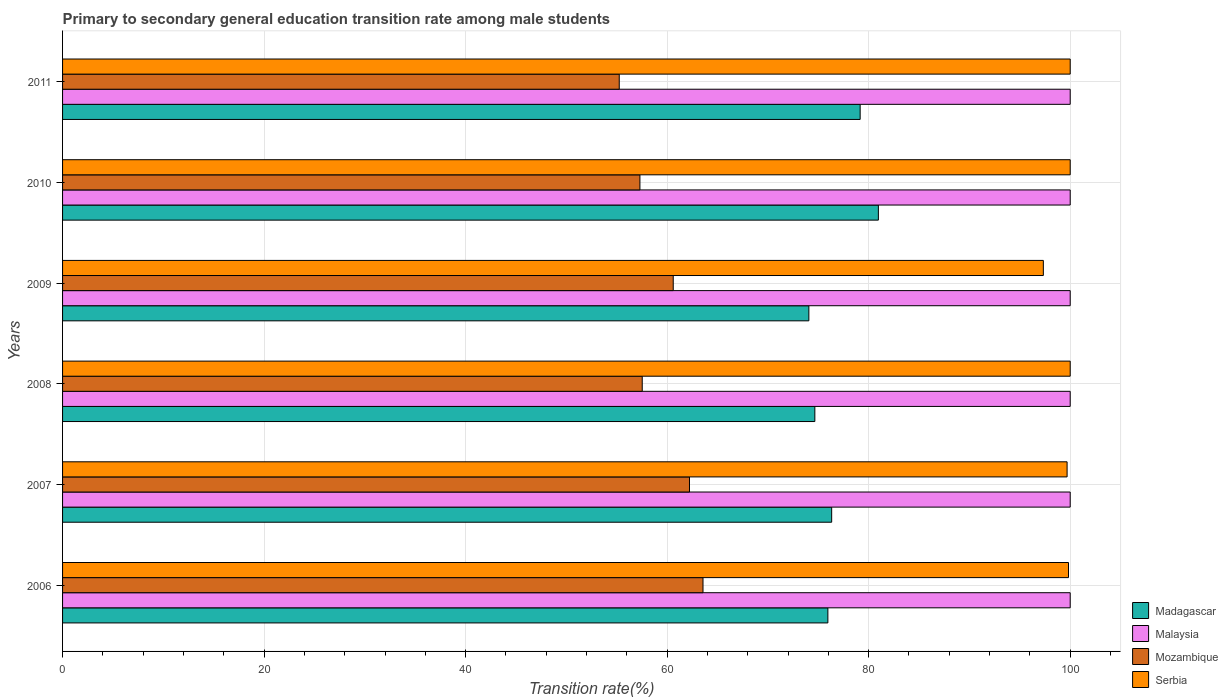How many groups of bars are there?
Make the answer very short. 6. Are the number of bars per tick equal to the number of legend labels?
Your response must be concise. Yes. What is the label of the 1st group of bars from the top?
Your response must be concise. 2011. What is the transition rate in Serbia in 2006?
Provide a succinct answer. 99.83. Across all years, what is the maximum transition rate in Serbia?
Your response must be concise. 100. Across all years, what is the minimum transition rate in Serbia?
Your response must be concise. 97.33. What is the total transition rate in Madagascar in the graph?
Your answer should be compact. 461.12. What is the difference between the transition rate in Malaysia in 2006 and that in 2009?
Your answer should be very brief. 0. What is the difference between the transition rate in Mozambique in 2006 and the transition rate in Malaysia in 2011?
Give a very brief answer. -36.44. What is the average transition rate in Mozambique per year?
Make the answer very short. 59.41. In the year 2009, what is the difference between the transition rate in Serbia and transition rate in Madagascar?
Your answer should be very brief. 23.27. In how many years, is the transition rate in Mozambique greater than 92 %?
Your answer should be very brief. 0. Is the difference between the transition rate in Serbia in 2006 and 2009 greater than the difference between the transition rate in Madagascar in 2006 and 2009?
Ensure brevity in your answer.  Yes. What is the difference between the highest and the lowest transition rate in Madagascar?
Your answer should be compact. 6.9. Is it the case that in every year, the sum of the transition rate in Mozambique and transition rate in Serbia is greater than the sum of transition rate in Malaysia and transition rate in Madagascar?
Give a very brief answer. Yes. What does the 3rd bar from the top in 2009 represents?
Ensure brevity in your answer.  Malaysia. What does the 1st bar from the bottom in 2006 represents?
Your response must be concise. Madagascar. Are all the bars in the graph horizontal?
Provide a succinct answer. Yes. How many years are there in the graph?
Offer a very short reply. 6. What is the difference between two consecutive major ticks on the X-axis?
Your response must be concise. 20. Are the values on the major ticks of X-axis written in scientific E-notation?
Your answer should be compact. No. How many legend labels are there?
Ensure brevity in your answer.  4. What is the title of the graph?
Your response must be concise. Primary to secondary general education transition rate among male students. Does "Luxembourg" appear as one of the legend labels in the graph?
Provide a short and direct response. No. What is the label or title of the X-axis?
Your answer should be compact. Transition rate(%). What is the Transition rate(%) of Madagascar in 2006?
Your answer should be compact. 75.95. What is the Transition rate(%) in Mozambique in 2006?
Your answer should be very brief. 63.56. What is the Transition rate(%) in Serbia in 2006?
Give a very brief answer. 99.83. What is the Transition rate(%) in Madagascar in 2007?
Offer a terse response. 76.33. What is the Transition rate(%) of Mozambique in 2007?
Offer a very short reply. 62.22. What is the Transition rate(%) in Serbia in 2007?
Offer a terse response. 99.69. What is the Transition rate(%) in Madagascar in 2008?
Ensure brevity in your answer.  74.66. What is the Transition rate(%) of Mozambique in 2008?
Your answer should be very brief. 57.53. What is the Transition rate(%) in Madagascar in 2009?
Offer a terse response. 74.06. What is the Transition rate(%) of Mozambique in 2009?
Make the answer very short. 60.6. What is the Transition rate(%) of Serbia in 2009?
Offer a very short reply. 97.33. What is the Transition rate(%) in Madagascar in 2010?
Your response must be concise. 80.96. What is the Transition rate(%) in Mozambique in 2010?
Your answer should be very brief. 57.3. What is the Transition rate(%) in Madagascar in 2011?
Provide a succinct answer. 79.15. What is the Transition rate(%) in Mozambique in 2011?
Offer a terse response. 55.25. Across all years, what is the maximum Transition rate(%) of Madagascar?
Your answer should be compact. 80.96. Across all years, what is the maximum Transition rate(%) in Malaysia?
Provide a succinct answer. 100. Across all years, what is the maximum Transition rate(%) of Mozambique?
Your response must be concise. 63.56. Across all years, what is the minimum Transition rate(%) in Madagascar?
Provide a short and direct response. 74.06. Across all years, what is the minimum Transition rate(%) in Malaysia?
Your answer should be compact. 100. Across all years, what is the minimum Transition rate(%) of Mozambique?
Provide a succinct answer. 55.25. Across all years, what is the minimum Transition rate(%) of Serbia?
Your answer should be very brief. 97.33. What is the total Transition rate(%) in Madagascar in the graph?
Keep it short and to the point. 461.12. What is the total Transition rate(%) of Malaysia in the graph?
Your answer should be compact. 600. What is the total Transition rate(%) in Mozambique in the graph?
Your answer should be very brief. 356.45. What is the total Transition rate(%) in Serbia in the graph?
Make the answer very short. 596.86. What is the difference between the Transition rate(%) in Madagascar in 2006 and that in 2007?
Your answer should be very brief. -0.38. What is the difference between the Transition rate(%) of Mozambique in 2006 and that in 2007?
Give a very brief answer. 1.34. What is the difference between the Transition rate(%) in Serbia in 2006 and that in 2007?
Provide a short and direct response. 0.14. What is the difference between the Transition rate(%) in Madagascar in 2006 and that in 2008?
Your answer should be compact. 1.29. What is the difference between the Transition rate(%) of Malaysia in 2006 and that in 2008?
Offer a very short reply. 0. What is the difference between the Transition rate(%) in Mozambique in 2006 and that in 2008?
Keep it short and to the point. 6.03. What is the difference between the Transition rate(%) of Serbia in 2006 and that in 2008?
Offer a terse response. -0.17. What is the difference between the Transition rate(%) of Madagascar in 2006 and that in 2009?
Provide a succinct answer. 1.89. What is the difference between the Transition rate(%) of Mozambique in 2006 and that in 2009?
Keep it short and to the point. 2.95. What is the difference between the Transition rate(%) in Serbia in 2006 and that in 2009?
Make the answer very short. 2.5. What is the difference between the Transition rate(%) in Madagascar in 2006 and that in 2010?
Offer a very short reply. -5.01. What is the difference between the Transition rate(%) of Mozambique in 2006 and that in 2010?
Your response must be concise. 6.26. What is the difference between the Transition rate(%) of Serbia in 2006 and that in 2010?
Make the answer very short. -0.17. What is the difference between the Transition rate(%) in Madagascar in 2006 and that in 2011?
Offer a very short reply. -3.2. What is the difference between the Transition rate(%) of Mozambique in 2006 and that in 2011?
Your answer should be compact. 8.31. What is the difference between the Transition rate(%) of Serbia in 2006 and that in 2011?
Give a very brief answer. -0.17. What is the difference between the Transition rate(%) of Madagascar in 2007 and that in 2008?
Offer a very short reply. 1.67. What is the difference between the Transition rate(%) of Malaysia in 2007 and that in 2008?
Offer a terse response. 0. What is the difference between the Transition rate(%) in Mozambique in 2007 and that in 2008?
Give a very brief answer. 4.69. What is the difference between the Transition rate(%) of Serbia in 2007 and that in 2008?
Keep it short and to the point. -0.31. What is the difference between the Transition rate(%) in Madagascar in 2007 and that in 2009?
Ensure brevity in your answer.  2.26. What is the difference between the Transition rate(%) in Mozambique in 2007 and that in 2009?
Your answer should be compact. 1.61. What is the difference between the Transition rate(%) in Serbia in 2007 and that in 2009?
Provide a succinct answer. 2.36. What is the difference between the Transition rate(%) of Madagascar in 2007 and that in 2010?
Keep it short and to the point. -4.64. What is the difference between the Transition rate(%) in Malaysia in 2007 and that in 2010?
Offer a very short reply. 0. What is the difference between the Transition rate(%) in Mozambique in 2007 and that in 2010?
Offer a very short reply. 4.92. What is the difference between the Transition rate(%) in Serbia in 2007 and that in 2010?
Your answer should be compact. -0.31. What is the difference between the Transition rate(%) in Madagascar in 2007 and that in 2011?
Ensure brevity in your answer.  -2.83. What is the difference between the Transition rate(%) in Malaysia in 2007 and that in 2011?
Your answer should be compact. 0. What is the difference between the Transition rate(%) in Mozambique in 2007 and that in 2011?
Give a very brief answer. 6.97. What is the difference between the Transition rate(%) in Serbia in 2007 and that in 2011?
Your response must be concise. -0.31. What is the difference between the Transition rate(%) of Madagascar in 2008 and that in 2009?
Your answer should be very brief. 0.59. What is the difference between the Transition rate(%) in Mozambique in 2008 and that in 2009?
Your response must be concise. -3.08. What is the difference between the Transition rate(%) of Serbia in 2008 and that in 2009?
Provide a succinct answer. 2.67. What is the difference between the Transition rate(%) of Madagascar in 2008 and that in 2010?
Offer a terse response. -6.3. What is the difference between the Transition rate(%) of Mozambique in 2008 and that in 2010?
Offer a terse response. 0.23. What is the difference between the Transition rate(%) in Serbia in 2008 and that in 2010?
Your answer should be compact. 0. What is the difference between the Transition rate(%) in Madagascar in 2008 and that in 2011?
Make the answer very short. -4.5. What is the difference between the Transition rate(%) in Malaysia in 2008 and that in 2011?
Offer a terse response. 0. What is the difference between the Transition rate(%) of Mozambique in 2008 and that in 2011?
Keep it short and to the point. 2.28. What is the difference between the Transition rate(%) of Madagascar in 2009 and that in 2010?
Keep it short and to the point. -6.9. What is the difference between the Transition rate(%) of Malaysia in 2009 and that in 2010?
Ensure brevity in your answer.  0. What is the difference between the Transition rate(%) of Mozambique in 2009 and that in 2010?
Your response must be concise. 3.3. What is the difference between the Transition rate(%) in Serbia in 2009 and that in 2010?
Provide a short and direct response. -2.67. What is the difference between the Transition rate(%) of Madagascar in 2009 and that in 2011?
Your answer should be compact. -5.09. What is the difference between the Transition rate(%) of Malaysia in 2009 and that in 2011?
Your response must be concise. 0. What is the difference between the Transition rate(%) in Mozambique in 2009 and that in 2011?
Offer a terse response. 5.36. What is the difference between the Transition rate(%) of Serbia in 2009 and that in 2011?
Give a very brief answer. -2.67. What is the difference between the Transition rate(%) in Madagascar in 2010 and that in 2011?
Keep it short and to the point. 1.81. What is the difference between the Transition rate(%) of Mozambique in 2010 and that in 2011?
Keep it short and to the point. 2.05. What is the difference between the Transition rate(%) in Serbia in 2010 and that in 2011?
Keep it short and to the point. 0. What is the difference between the Transition rate(%) in Madagascar in 2006 and the Transition rate(%) in Malaysia in 2007?
Ensure brevity in your answer.  -24.05. What is the difference between the Transition rate(%) in Madagascar in 2006 and the Transition rate(%) in Mozambique in 2007?
Your response must be concise. 13.73. What is the difference between the Transition rate(%) in Madagascar in 2006 and the Transition rate(%) in Serbia in 2007?
Ensure brevity in your answer.  -23.74. What is the difference between the Transition rate(%) of Malaysia in 2006 and the Transition rate(%) of Mozambique in 2007?
Ensure brevity in your answer.  37.78. What is the difference between the Transition rate(%) of Malaysia in 2006 and the Transition rate(%) of Serbia in 2007?
Give a very brief answer. 0.31. What is the difference between the Transition rate(%) of Mozambique in 2006 and the Transition rate(%) of Serbia in 2007?
Offer a terse response. -36.13. What is the difference between the Transition rate(%) in Madagascar in 2006 and the Transition rate(%) in Malaysia in 2008?
Provide a succinct answer. -24.05. What is the difference between the Transition rate(%) of Madagascar in 2006 and the Transition rate(%) of Mozambique in 2008?
Offer a terse response. 18.42. What is the difference between the Transition rate(%) in Madagascar in 2006 and the Transition rate(%) in Serbia in 2008?
Your answer should be very brief. -24.05. What is the difference between the Transition rate(%) of Malaysia in 2006 and the Transition rate(%) of Mozambique in 2008?
Your answer should be very brief. 42.47. What is the difference between the Transition rate(%) in Malaysia in 2006 and the Transition rate(%) in Serbia in 2008?
Provide a succinct answer. 0. What is the difference between the Transition rate(%) of Mozambique in 2006 and the Transition rate(%) of Serbia in 2008?
Provide a succinct answer. -36.44. What is the difference between the Transition rate(%) of Madagascar in 2006 and the Transition rate(%) of Malaysia in 2009?
Make the answer very short. -24.05. What is the difference between the Transition rate(%) in Madagascar in 2006 and the Transition rate(%) in Mozambique in 2009?
Provide a short and direct response. 15.35. What is the difference between the Transition rate(%) in Madagascar in 2006 and the Transition rate(%) in Serbia in 2009?
Offer a terse response. -21.38. What is the difference between the Transition rate(%) of Malaysia in 2006 and the Transition rate(%) of Mozambique in 2009?
Your response must be concise. 39.4. What is the difference between the Transition rate(%) of Malaysia in 2006 and the Transition rate(%) of Serbia in 2009?
Offer a terse response. 2.67. What is the difference between the Transition rate(%) of Mozambique in 2006 and the Transition rate(%) of Serbia in 2009?
Offer a terse response. -33.78. What is the difference between the Transition rate(%) in Madagascar in 2006 and the Transition rate(%) in Malaysia in 2010?
Give a very brief answer. -24.05. What is the difference between the Transition rate(%) of Madagascar in 2006 and the Transition rate(%) of Mozambique in 2010?
Keep it short and to the point. 18.65. What is the difference between the Transition rate(%) in Madagascar in 2006 and the Transition rate(%) in Serbia in 2010?
Your response must be concise. -24.05. What is the difference between the Transition rate(%) of Malaysia in 2006 and the Transition rate(%) of Mozambique in 2010?
Offer a terse response. 42.7. What is the difference between the Transition rate(%) of Mozambique in 2006 and the Transition rate(%) of Serbia in 2010?
Offer a terse response. -36.44. What is the difference between the Transition rate(%) in Madagascar in 2006 and the Transition rate(%) in Malaysia in 2011?
Offer a very short reply. -24.05. What is the difference between the Transition rate(%) in Madagascar in 2006 and the Transition rate(%) in Mozambique in 2011?
Keep it short and to the point. 20.7. What is the difference between the Transition rate(%) of Madagascar in 2006 and the Transition rate(%) of Serbia in 2011?
Provide a succinct answer. -24.05. What is the difference between the Transition rate(%) of Malaysia in 2006 and the Transition rate(%) of Mozambique in 2011?
Provide a short and direct response. 44.75. What is the difference between the Transition rate(%) of Malaysia in 2006 and the Transition rate(%) of Serbia in 2011?
Give a very brief answer. 0. What is the difference between the Transition rate(%) in Mozambique in 2006 and the Transition rate(%) in Serbia in 2011?
Keep it short and to the point. -36.44. What is the difference between the Transition rate(%) in Madagascar in 2007 and the Transition rate(%) in Malaysia in 2008?
Offer a very short reply. -23.67. What is the difference between the Transition rate(%) in Madagascar in 2007 and the Transition rate(%) in Mozambique in 2008?
Ensure brevity in your answer.  18.8. What is the difference between the Transition rate(%) of Madagascar in 2007 and the Transition rate(%) of Serbia in 2008?
Your response must be concise. -23.67. What is the difference between the Transition rate(%) of Malaysia in 2007 and the Transition rate(%) of Mozambique in 2008?
Your response must be concise. 42.47. What is the difference between the Transition rate(%) of Malaysia in 2007 and the Transition rate(%) of Serbia in 2008?
Offer a terse response. 0. What is the difference between the Transition rate(%) of Mozambique in 2007 and the Transition rate(%) of Serbia in 2008?
Your response must be concise. -37.78. What is the difference between the Transition rate(%) in Madagascar in 2007 and the Transition rate(%) in Malaysia in 2009?
Your answer should be very brief. -23.67. What is the difference between the Transition rate(%) of Madagascar in 2007 and the Transition rate(%) of Mozambique in 2009?
Your answer should be compact. 15.72. What is the difference between the Transition rate(%) in Madagascar in 2007 and the Transition rate(%) in Serbia in 2009?
Offer a very short reply. -21.01. What is the difference between the Transition rate(%) of Malaysia in 2007 and the Transition rate(%) of Mozambique in 2009?
Make the answer very short. 39.4. What is the difference between the Transition rate(%) of Malaysia in 2007 and the Transition rate(%) of Serbia in 2009?
Make the answer very short. 2.67. What is the difference between the Transition rate(%) of Mozambique in 2007 and the Transition rate(%) of Serbia in 2009?
Give a very brief answer. -35.12. What is the difference between the Transition rate(%) in Madagascar in 2007 and the Transition rate(%) in Malaysia in 2010?
Provide a short and direct response. -23.67. What is the difference between the Transition rate(%) of Madagascar in 2007 and the Transition rate(%) of Mozambique in 2010?
Your answer should be very brief. 19.03. What is the difference between the Transition rate(%) of Madagascar in 2007 and the Transition rate(%) of Serbia in 2010?
Give a very brief answer. -23.67. What is the difference between the Transition rate(%) of Malaysia in 2007 and the Transition rate(%) of Mozambique in 2010?
Offer a very short reply. 42.7. What is the difference between the Transition rate(%) in Malaysia in 2007 and the Transition rate(%) in Serbia in 2010?
Your answer should be compact. 0. What is the difference between the Transition rate(%) of Mozambique in 2007 and the Transition rate(%) of Serbia in 2010?
Your response must be concise. -37.78. What is the difference between the Transition rate(%) of Madagascar in 2007 and the Transition rate(%) of Malaysia in 2011?
Make the answer very short. -23.67. What is the difference between the Transition rate(%) of Madagascar in 2007 and the Transition rate(%) of Mozambique in 2011?
Ensure brevity in your answer.  21.08. What is the difference between the Transition rate(%) in Madagascar in 2007 and the Transition rate(%) in Serbia in 2011?
Your answer should be compact. -23.67. What is the difference between the Transition rate(%) in Malaysia in 2007 and the Transition rate(%) in Mozambique in 2011?
Your answer should be compact. 44.75. What is the difference between the Transition rate(%) of Mozambique in 2007 and the Transition rate(%) of Serbia in 2011?
Offer a very short reply. -37.78. What is the difference between the Transition rate(%) in Madagascar in 2008 and the Transition rate(%) in Malaysia in 2009?
Provide a succinct answer. -25.34. What is the difference between the Transition rate(%) of Madagascar in 2008 and the Transition rate(%) of Mozambique in 2009?
Your answer should be compact. 14.05. What is the difference between the Transition rate(%) of Madagascar in 2008 and the Transition rate(%) of Serbia in 2009?
Provide a short and direct response. -22.68. What is the difference between the Transition rate(%) of Malaysia in 2008 and the Transition rate(%) of Mozambique in 2009?
Give a very brief answer. 39.4. What is the difference between the Transition rate(%) in Malaysia in 2008 and the Transition rate(%) in Serbia in 2009?
Ensure brevity in your answer.  2.67. What is the difference between the Transition rate(%) of Mozambique in 2008 and the Transition rate(%) of Serbia in 2009?
Provide a short and direct response. -39.81. What is the difference between the Transition rate(%) of Madagascar in 2008 and the Transition rate(%) of Malaysia in 2010?
Give a very brief answer. -25.34. What is the difference between the Transition rate(%) of Madagascar in 2008 and the Transition rate(%) of Mozambique in 2010?
Offer a very short reply. 17.36. What is the difference between the Transition rate(%) in Madagascar in 2008 and the Transition rate(%) in Serbia in 2010?
Provide a short and direct response. -25.34. What is the difference between the Transition rate(%) of Malaysia in 2008 and the Transition rate(%) of Mozambique in 2010?
Ensure brevity in your answer.  42.7. What is the difference between the Transition rate(%) of Malaysia in 2008 and the Transition rate(%) of Serbia in 2010?
Give a very brief answer. 0. What is the difference between the Transition rate(%) in Mozambique in 2008 and the Transition rate(%) in Serbia in 2010?
Your answer should be very brief. -42.47. What is the difference between the Transition rate(%) of Madagascar in 2008 and the Transition rate(%) of Malaysia in 2011?
Your response must be concise. -25.34. What is the difference between the Transition rate(%) in Madagascar in 2008 and the Transition rate(%) in Mozambique in 2011?
Your response must be concise. 19.41. What is the difference between the Transition rate(%) of Madagascar in 2008 and the Transition rate(%) of Serbia in 2011?
Offer a terse response. -25.34. What is the difference between the Transition rate(%) of Malaysia in 2008 and the Transition rate(%) of Mozambique in 2011?
Provide a succinct answer. 44.75. What is the difference between the Transition rate(%) of Malaysia in 2008 and the Transition rate(%) of Serbia in 2011?
Ensure brevity in your answer.  0. What is the difference between the Transition rate(%) in Mozambique in 2008 and the Transition rate(%) in Serbia in 2011?
Offer a very short reply. -42.47. What is the difference between the Transition rate(%) in Madagascar in 2009 and the Transition rate(%) in Malaysia in 2010?
Your answer should be very brief. -25.94. What is the difference between the Transition rate(%) of Madagascar in 2009 and the Transition rate(%) of Mozambique in 2010?
Offer a terse response. 16.76. What is the difference between the Transition rate(%) of Madagascar in 2009 and the Transition rate(%) of Serbia in 2010?
Offer a very short reply. -25.94. What is the difference between the Transition rate(%) in Malaysia in 2009 and the Transition rate(%) in Mozambique in 2010?
Your answer should be very brief. 42.7. What is the difference between the Transition rate(%) of Mozambique in 2009 and the Transition rate(%) of Serbia in 2010?
Offer a terse response. -39.4. What is the difference between the Transition rate(%) in Madagascar in 2009 and the Transition rate(%) in Malaysia in 2011?
Provide a short and direct response. -25.94. What is the difference between the Transition rate(%) of Madagascar in 2009 and the Transition rate(%) of Mozambique in 2011?
Provide a short and direct response. 18.82. What is the difference between the Transition rate(%) of Madagascar in 2009 and the Transition rate(%) of Serbia in 2011?
Ensure brevity in your answer.  -25.94. What is the difference between the Transition rate(%) in Malaysia in 2009 and the Transition rate(%) in Mozambique in 2011?
Your response must be concise. 44.75. What is the difference between the Transition rate(%) of Malaysia in 2009 and the Transition rate(%) of Serbia in 2011?
Your response must be concise. 0. What is the difference between the Transition rate(%) of Mozambique in 2009 and the Transition rate(%) of Serbia in 2011?
Your answer should be very brief. -39.4. What is the difference between the Transition rate(%) in Madagascar in 2010 and the Transition rate(%) in Malaysia in 2011?
Your answer should be compact. -19.04. What is the difference between the Transition rate(%) of Madagascar in 2010 and the Transition rate(%) of Mozambique in 2011?
Provide a succinct answer. 25.72. What is the difference between the Transition rate(%) of Madagascar in 2010 and the Transition rate(%) of Serbia in 2011?
Your answer should be very brief. -19.04. What is the difference between the Transition rate(%) of Malaysia in 2010 and the Transition rate(%) of Mozambique in 2011?
Provide a short and direct response. 44.75. What is the difference between the Transition rate(%) of Malaysia in 2010 and the Transition rate(%) of Serbia in 2011?
Your response must be concise. 0. What is the difference between the Transition rate(%) in Mozambique in 2010 and the Transition rate(%) in Serbia in 2011?
Offer a terse response. -42.7. What is the average Transition rate(%) in Madagascar per year?
Keep it short and to the point. 76.85. What is the average Transition rate(%) of Malaysia per year?
Ensure brevity in your answer.  100. What is the average Transition rate(%) in Mozambique per year?
Your answer should be compact. 59.41. What is the average Transition rate(%) in Serbia per year?
Your answer should be compact. 99.48. In the year 2006, what is the difference between the Transition rate(%) of Madagascar and Transition rate(%) of Malaysia?
Give a very brief answer. -24.05. In the year 2006, what is the difference between the Transition rate(%) of Madagascar and Transition rate(%) of Mozambique?
Give a very brief answer. 12.39. In the year 2006, what is the difference between the Transition rate(%) of Madagascar and Transition rate(%) of Serbia?
Offer a very short reply. -23.88. In the year 2006, what is the difference between the Transition rate(%) of Malaysia and Transition rate(%) of Mozambique?
Keep it short and to the point. 36.44. In the year 2006, what is the difference between the Transition rate(%) of Malaysia and Transition rate(%) of Serbia?
Keep it short and to the point. 0.17. In the year 2006, what is the difference between the Transition rate(%) in Mozambique and Transition rate(%) in Serbia?
Make the answer very short. -36.27. In the year 2007, what is the difference between the Transition rate(%) in Madagascar and Transition rate(%) in Malaysia?
Your answer should be compact. -23.67. In the year 2007, what is the difference between the Transition rate(%) of Madagascar and Transition rate(%) of Mozambique?
Your answer should be very brief. 14.11. In the year 2007, what is the difference between the Transition rate(%) in Madagascar and Transition rate(%) in Serbia?
Make the answer very short. -23.36. In the year 2007, what is the difference between the Transition rate(%) of Malaysia and Transition rate(%) of Mozambique?
Your answer should be very brief. 37.78. In the year 2007, what is the difference between the Transition rate(%) in Malaysia and Transition rate(%) in Serbia?
Offer a very short reply. 0.31. In the year 2007, what is the difference between the Transition rate(%) of Mozambique and Transition rate(%) of Serbia?
Your answer should be very brief. -37.48. In the year 2008, what is the difference between the Transition rate(%) in Madagascar and Transition rate(%) in Malaysia?
Offer a terse response. -25.34. In the year 2008, what is the difference between the Transition rate(%) in Madagascar and Transition rate(%) in Mozambique?
Offer a very short reply. 17.13. In the year 2008, what is the difference between the Transition rate(%) in Madagascar and Transition rate(%) in Serbia?
Offer a terse response. -25.34. In the year 2008, what is the difference between the Transition rate(%) of Malaysia and Transition rate(%) of Mozambique?
Your response must be concise. 42.47. In the year 2008, what is the difference between the Transition rate(%) in Mozambique and Transition rate(%) in Serbia?
Keep it short and to the point. -42.47. In the year 2009, what is the difference between the Transition rate(%) of Madagascar and Transition rate(%) of Malaysia?
Provide a short and direct response. -25.94. In the year 2009, what is the difference between the Transition rate(%) of Madagascar and Transition rate(%) of Mozambique?
Provide a succinct answer. 13.46. In the year 2009, what is the difference between the Transition rate(%) in Madagascar and Transition rate(%) in Serbia?
Provide a short and direct response. -23.27. In the year 2009, what is the difference between the Transition rate(%) of Malaysia and Transition rate(%) of Mozambique?
Your response must be concise. 39.4. In the year 2009, what is the difference between the Transition rate(%) in Malaysia and Transition rate(%) in Serbia?
Make the answer very short. 2.67. In the year 2009, what is the difference between the Transition rate(%) of Mozambique and Transition rate(%) of Serbia?
Ensure brevity in your answer.  -36.73. In the year 2010, what is the difference between the Transition rate(%) of Madagascar and Transition rate(%) of Malaysia?
Your response must be concise. -19.04. In the year 2010, what is the difference between the Transition rate(%) in Madagascar and Transition rate(%) in Mozambique?
Give a very brief answer. 23.66. In the year 2010, what is the difference between the Transition rate(%) of Madagascar and Transition rate(%) of Serbia?
Your answer should be compact. -19.04. In the year 2010, what is the difference between the Transition rate(%) in Malaysia and Transition rate(%) in Mozambique?
Ensure brevity in your answer.  42.7. In the year 2010, what is the difference between the Transition rate(%) of Malaysia and Transition rate(%) of Serbia?
Your answer should be very brief. 0. In the year 2010, what is the difference between the Transition rate(%) of Mozambique and Transition rate(%) of Serbia?
Your response must be concise. -42.7. In the year 2011, what is the difference between the Transition rate(%) of Madagascar and Transition rate(%) of Malaysia?
Give a very brief answer. -20.85. In the year 2011, what is the difference between the Transition rate(%) in Madagascar and Transition rate(%) in Mozambique?
Provide a short and direct response. 23.91. In the year 2011, what is the difference between the Transition rate(%) of Madagascar and Transition rate(%) of Serbia?
Your answer should be very brief. -20.85. In the year 2011, what is the difference between the Transition rate(%) in Malaysia and Transition rate(%) in Mozambique?
Keep it short and to the point. 44.75. In the year 2011, what is the difference between the Transition rate(%) of Malaysia and Transition rate(%) of Serbia?
Keep it short and to the point. 0. In the year 2011, what is the difference between the Transition rate(%) of Mozambique and Transition rate(%) of Serbia?
Make the answer very short. -44.75. What is the ratio of the Transition rate(%) in Madagascar in 2006 to that in 2007?
Your response must be concise. 1. What is the ratio of the Transition rate(%) of Mozambique in 2006 to that in 2007?
Provide a succinct answer. 1.02. What is the ratio of the Transition rate(%) of Serbia in 2006 to that in 2007?
Your answer should be compact. 1. What is the ratio of the Transition rate(%) in Madagascar in 2006 to that in 2008?
Offer a very short reply. 1.02. What is the ratio of the Transition rate(%) of Mozambique in 2006 to that in 2008?
Provide a succinct answer. 1.1. What is the ratio of the Transition rate(%) in Serbia in 2006 to that in 2008?
Provide a succinct answer. 1. What is the ratio of the Transition rate(%) in Madagascar in 2006 to that in 2009?
Your answer should be very brief. 1.03. What is the ratio of the Transition rate(%) of Mozambique in 2006 to that in 2009?
Give a very brief answer. 1.05. What is the ratio of the Transition rate(%) of Serbia in 2006 to that in 2009?
Make the answer very short. 1.03. What is the ratio of the Transition rate(%) of Madagascar in 2006 to that in 2010?
Offer a very short reply. 0.94. What is the ratio of the Transition rate(%) of Malaysia in 2006 to that in 2010?
Offer a very short reply. 1. What is the ratio of the Transition rate(%) in Mozambique in 2006 to that in 2010?
Provide a short and direct response. 1.11. What is the ratio of the Transition rate(%) of Serbia in 2006 to that in 2010?
Make the answer very short. 1. What is the ratio of the Transition rate(%) in Madagascar in 2006 to that in 2011?
Your answer should be very brief. 0.96. What is the ratio of the Transition rate(%) of Malaysia in 2006 to that in 2011?
Offer a terse response. 1. What is the ratio of the Transition rate(%) of Mozambique in 2006 to that in 2011?
Give a very brief answer. 1.15. What is the ratio of the Transition rate(%) in Serbia in 2006 to that in 2011?
Provide a short and direct response. 1. What is the ratio of the Transition rate(%) in Madagascar in 2007 to that in 2008?
Give a very brief answer. 1.02. What is the ratio of the Transition rate(%) in Mozambique in 2007 to that in 2008?
Your answer should be compact. 1.08. What is the ratio of the Transition rate(%) of Serbia in 2007 to that in 2008?
Your response must be concise. 1. What is the ratio of the Transition rate(%) of Madagascar in 2007 to that in 2009?
Your answer should be very brief. 1.03. What is the ratio of the Transition rate(%) in Mozambique in 2007 to that in 2009?
Provide a short and direct response. 1.03. What is the ratio of the Transition rate(%) in Serbia in 2007 to that in 2009?
Offer a very short reply. 1.02. What is the ratio of the Transition rate(%) in Madagascar in 2007 to that in 2010?
Your answer should be very brief. 0.94. What is the ratio of the Transition rate(%) of Malaysia in 2007 to that in 2010?
Your answer should be very brief. 1. What is the ratio of the Transition rate(%) in Mozambique in 2007 to that in 2010?
Your response must be concise. 1.09. What is the ratio of the Transition rate(%) of Serbia in 2007 to that in 2010?
Ensure brevity in your answer.  1. What is the ratio of the Transition rate(%) in Madagascar in 2007 to that in 2011?
Keep it short and to the point. 0.96. What is the ratio of the Transition rate(%) of Mozambique in 2007 to that in 2011?
Make the answer very short. 1.13. What is the ratio of the Transition rate(%) in Serbia in 2007 to that in 2011?
Keep it short and to the point. 1. What is the ratio of the Transition rate(%) of Malaysia in 2008 to that in 2009?
Your answer should be very brief. 1. What is the ratio of the Transition rate(%) of Mozambique in 2008 to that in 2009?
Offer a very short reply. 0.95. What is the ratio of the Transition rate(%) in Serbia in 2008 to that in 2009?
Offer a terse response. 1.03. What is the ratio of the Transition rate(%) in Madagascar in 2008 to that in 2010?
Your response must be concise. 0.92. What is the ratio of the Transition rate(%) in Malaysia in 2008 to that in 2010?
Keep it short and to the point. 1. What is the ratio of the Transition rate(%) of Madagascar in 2008 to that in 2011?
Provide a succinct answer. 0.94. What is the ratio of the Transition rate(%) in Malaysia in 2008 to that in 2011?
Ensure brevity in your answer.  1. What is the ratio of the Transition rate(%) of Mozambique in 2008 to that in 2011?
Offer a terse response. 1.04. What is the ratio of the Transition rate(%) in Madagascar in 2009 to that in 2010?
Provide a succinct answer. 0.91. What is the ratio of the Transition rate(%) in Malaysia in 2009 to that in 2010?
Offer a terse response. 1. What is the ratio of the Transition rate(%) of Mozambique in 2009 to that in 2010?
Give a very brief answer. 1.06. What is the ratio of the Transition rate(%) in Serbia in 2009 to that in 2010?
Give a very brief answer. 0.97. What is the ratio of the Transition rate(%) in Madagascar in 2009 to that in 2011?
Offer a terse response. 0.94. What is the ratio of the Transition rate(%) in Mozambique in 2009 to that in 2011?
Offer a terse response. 1.1. What is the ratio of the Transition rate(%) in Serbia in 2009 to that in 2011?
Give a very brief answer. 0.97. What is the ratio of the Transition rate(%) in Madagascar in 2010 to that in 2011?
Provide a succinct answer. 1.02. What is the ratio of the Transition rate(%) in Mozambique in 2010 to that in 2011?
Offer a very short reply. 1.04. What is the ratio of the Transition rate(%) in Serbia in 2010 to that in 2011?
Give a very brief answer. 1. What is the difference between the highest and the second highest Transition rate(%) in Madagascar?
Make the answer very short. 1.81. What is the difference between the highest and the second highest Transition rate(%) in Mozambique?
Ensure brevity in your answer.  1.34. What is the difference between the highest and the lowest Transition rate(%) in Madagascar?
Offer a terse response. 6.9. What is the difference between the highest and the lowest Transition rate(%) in Malaysia?
Provide a succinct answer. 0. What is the difference between the highest and the lowest Transition rate(%) in Mozambique?
Give a very brief answer. 8.31. What is the difference between the highest and the lowest Transition rate(%) in Serbia?
Your answer should be compact. 2.67. 